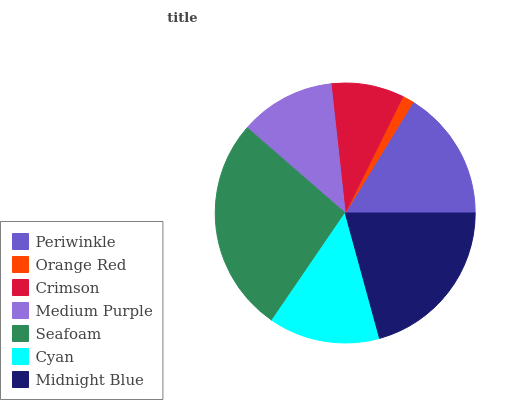Is Orange Red the minimum?
Answer yes or no. Yes. Is Seafoam the maximum?
Answer yes or no. Yes. Is Crimson the minimum?
Answer yes or no. No. Is Crimson the maximum?
Answer yes or no. No. Is Crimson greater than Orange Red?
Answer yes or no. Yes. Is Orange Red less than Crimson?
Answer yes or no. Yes. Is Orange Red greater than Crimson?
Answer yes or no. No. Is Crimson less than Orange Red?
Answer yes or no. No. Is Cyan the high median?
Answer yes or no. Yes. Is Cyan the low median?
Answer yes or no. Yes. Is Seafoam the high median?
Answer yes or no. No. Is Crimson the low median?
Answer yes or no. No. 